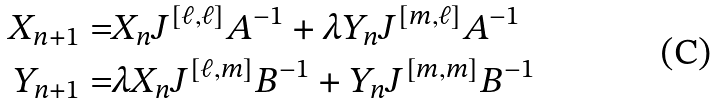<formula> <loc_0><loc_0><loc_500><loc_500>X _ { n + 1 } = & X _ { n } J ^ { [ \ell , \ell ] } A ^ { - 1 } + \lambda Y _ { n } J ^ { [ m , \ell ] } A ^ { - 1 } \\ Y _ { n + 1 } = & \lambda X _ { n } J ^ { [ \ell , m ] } B ^ { - 1 } + Y _ { n } J ^ { [ m , m ] } B ^ { - 1 }</formula> 